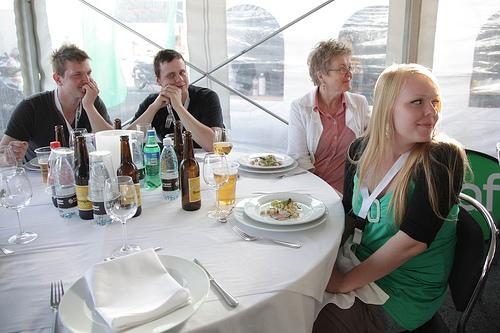What emotions can be inferred from the image? The people seem relaxed and engaged in friendly conversation, enjoying their meal together. Can you describe the table setup in detail? The table has a white tablecloth, plates of food, bottles of alcohol, empty wine glasses, a cup of beer, table napkins, and silverware including forks. Identify the type of gathering portrayed in this picture. The image portrays a casual dining gathering among friends. How many people are present in the image and how many empty bottles of alcohol can you count? There are four people and four empty bottles of alcohol. What are the main colors of clothing that the people in the image are wearing? Black, green, pink, and white. What are some of the items found on the table? White plates of food, bottles of alcohol, empty wine glasses, a cup of beer, table napkins, and silverware such as forks. Provide a short description of the scene, focusing on object interactions. People sitting at a round table, eating and drinking, with their hands near plates of food and beverages, engaged in conversation. Approximately how many place settings are there on the table? There are about four place settings on the table. What is the primary action happening in the image? Four people are sitting at a round dining table with food and drinks, engaging in conversation. Please give a brief description of the individuals in the image. There are two men wearing black shirts, a woman in a green and black shirt, and another woman in a pink shirt with a white sweater. Is there a pizza on one of the plates on the table? There are white plates with food, but no mention of a pizza on any of the plates. What item is present on top of a white napkin on the table? A plate is on top of the white napkin. Can you find a woman wearing a blue shirt smiling at the camera? There is a woman in a pink shirt with a white sweater and a girl in a green shirt, but no woman wearing a blue shirt or smiling at the camera. What color shirt is the girl with blonde hair wearing? Green and black shirt What is the dominant color of silverware in the image? Silver Are there any objects out of place or not expected in a dining scene? No, all objects seem appropriate for a dining scene. How many people can be seen wearing a black shirt in the image? Two people are wearing black shirts. What kind of interaction do you see between the people and objects in the image? People are having a meal and conversation around the table. Count the number of empty bottles on the table. 4 empty bottles Provide an appropriate caption describing the central theme of the image.  A group of friends enjoying a meal together at a round table Identify the main sentiment being displayed in the image. Positive social interactions Can you locate a square table in the image covered with a red tablecloth? The table in the image is round and has a white tablecloth on it, not a square table with a red tablecloth. Count the total number of people sitting at the table. Four people are sitting at the table. Which two objects are closest to each other in terms of height? An empty bottle of alcohol (X:171 Y:117 Width:12 Height:12) and an empty bottle of alcohol (X:70 Y:132 Width:21 Height:21) Is there a girl wearing eyeglasses present in the image? Yes, a woman with eyeglasses is present. Is there a woman wearing a white sweater in the image? Yes, a woman is wearing a white sweater. Is there a steak knife visible on the table? No, there is no steak knife visible. List three different types of objects you can see in the image. dining table, empty bottles, plates of food Locate the area with the highest density of empty wine glasses. X:1 Y:147 Width:230 Height:230 Where is the large dog sitting under the table? No dog or any animal is mentioned in the image, making the instruction misleading. Describe the overall quality of the image. The image is clear, and the objects are easily recognizable. Can you see an open laptop on the table next to the empty wine glasses? There is no mention of a laptop or any electronic device in the image, making the instruction misleading. What type of drink is in the cup on the table? Beer Locate the "fork laying on the table." X:225 Y:217 Width:82 Height:82 Can you point out a child sitting next to the people in black shirts? There are no children mentioned in the image, only adult men and women. 